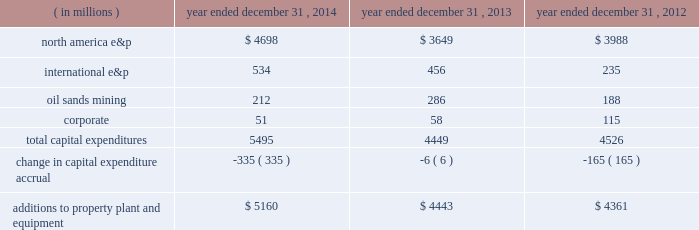Additions to property , plant and equipment are our most significant use of cash and cash equivalents .
The table shows capital expenditures related to continuing operations by segment and reconciles to additions to property , plant and equipment as presented in the consolidated statements of cash flows for 2014 , 2013 and 2012: .
As of december 31 , 2014 , we had repurchased a total of 121 million common shares at a cost of $ 4.7 billion , including 29 million shares at a cost of $ 1 billion in the first six months of 2014 and 14 million shares at a cost of $ 500 million in the third quarter of 2013 .
See item 8 .
Financial statements and supplementary data 2013 note 22 to the consolidated financial statements for discussion of purchases of common stock .
Liquidity and capital resources our main sources of liquidity are cash and cash equivalents , internally generated cash flow from operations , continued access to capital markets , our committed revolving credit facility and sales of non-strategic assets .
Our working capital requirements are supported by these sources and we may issue commercial paper backed by our $ 2.5 billion revolving credit facility to meet short-term cash requirements .
Because of the alternatives available to us as discussed above and access to capital markets through the shelf registration discussed below , we believe that our short-term and long-term liquidity is adequate to fund not only our current operations , but also our near-term and long-term funding requirements including our capital spending programs , dividend payments , defined benefit plan contributions , repayment of debt maturities and other amounts that may ultimately be paid in connection with contingencies .
At december 31 , 2014 , we had approximately $ 4.9 billion of liquidity consisting of $ 2.4 billion in cash and cash equivalents and $ 2.5 billion availability under our revolving credit facility .
As discussed in more detail below in 201coutlook 201d , we are targeting a $ 3.5 billion budget for 2015 .
Based on our projected 2015 cash outlays for our capital program and dividends , we expect to outspend our cash flows from operations for the year .
We will be constantly monitoring our available liquidity during 2015 and we have the flexibility to adjust our budget throughout the year in response to the commodity price environment .
We will also continue to drive the fundamentals of expense management , including organizational capacity and operational reliability .
Capital resources credit arrangements and borrowings in may 2014 , we amended our $ 2.5 billion unsecured revolving credit facility and extended the maturity to may 2019 .
See note 16 to the consolidated financial statements for additional terms and rates .
At december 31 , 2014 , we had no borrowings against our revolving credit facility and no amounts outstanding under our u.s .
Commercial paper program that is backed by the revolving credit facility .
At december 31 , 2014 , we had $ 6391 million in long-term debt outstanding , and $ 1068 million is due within one year , of which the majority is due in the fourth quarter of 2015 .
We do not have any triggers on any of our corporate debt that would cause an event of default in the case of a downgrade of our credit ratings .
Shelf registration we have a universal shelf registration statement filed with the sec , under which we , as "well-known seasoned issuer" for purposes of sec rules , have the ability to issue and sell an indeterminate amount of various types of debt and equity securities from time to time. .
What percentage as of december 31 , 2014 liquidity consisted of cash and cash equivalents? 
Computations: (2.4 / (2.4 + 2.5))
Answer: 0.4898. 